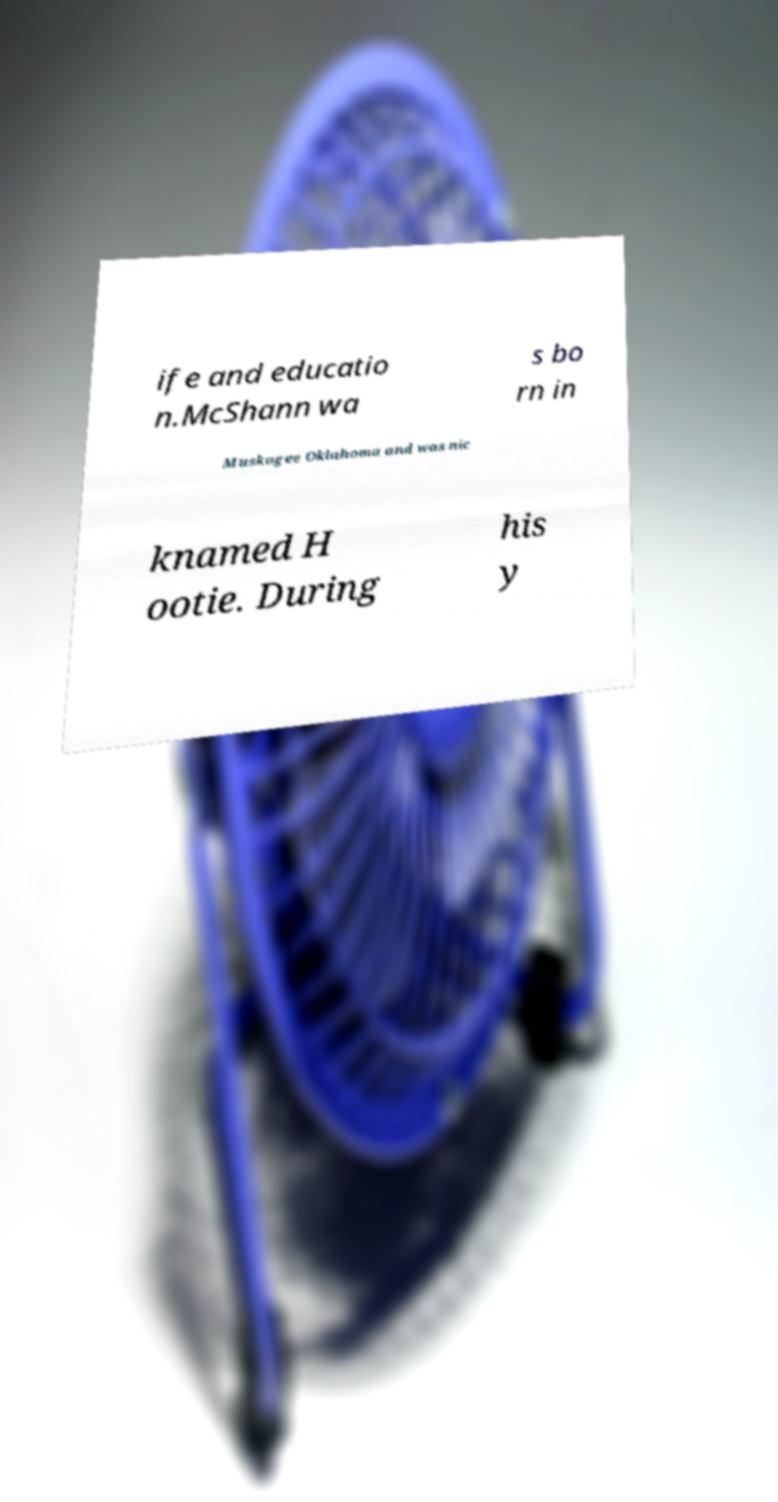Could you assist in decoding the text presented in this image and type it out clearly? ife and educatio n.McShann wa s bo rn in Muskogee Oklahoma and was nic knamed H ootie. During his y 